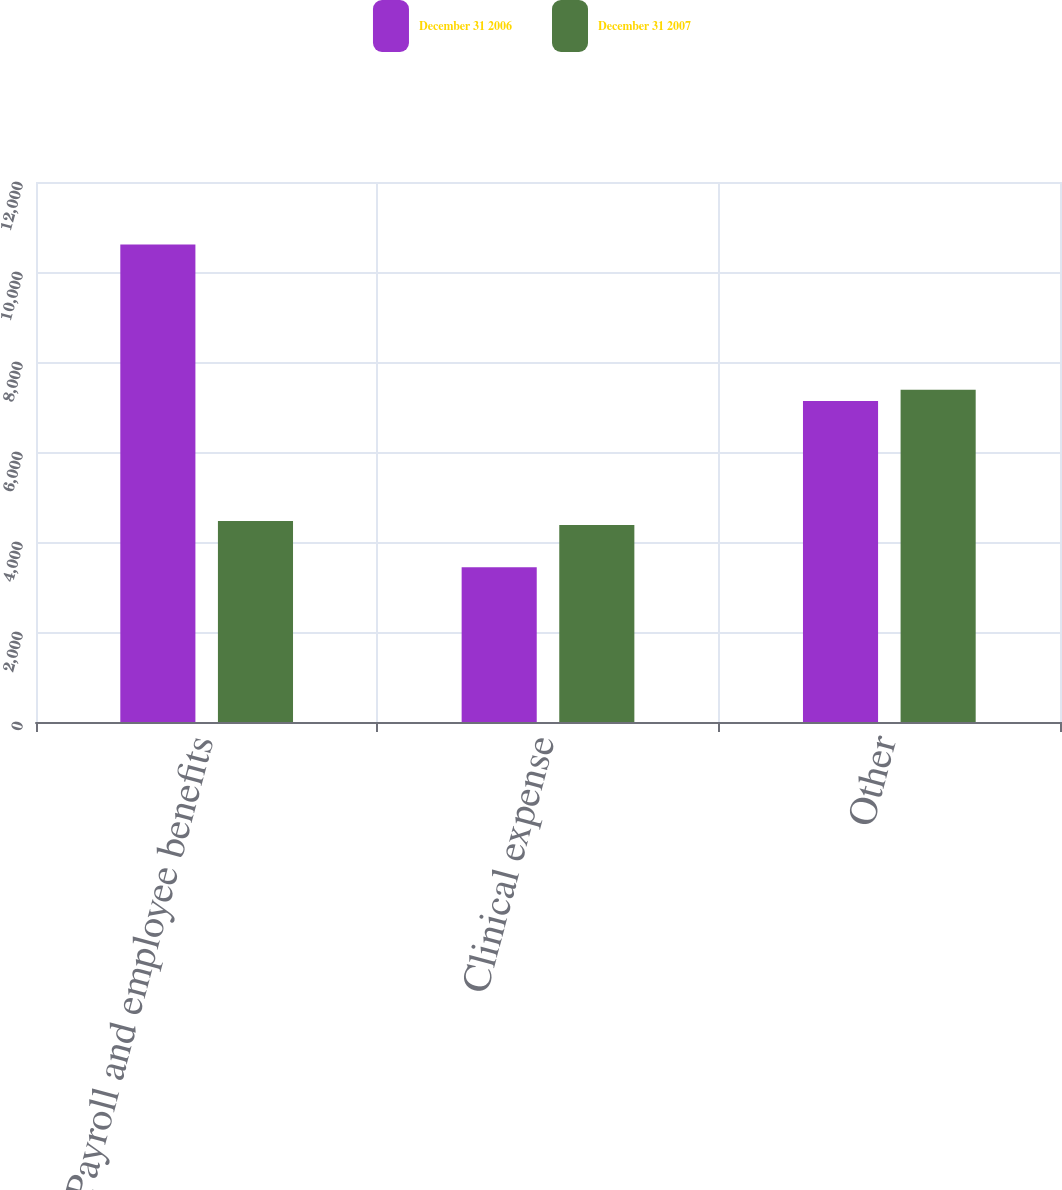Convert chart. <chart><loc_0><loc_0><loc_500><loc_500><stacked_bar_chart><ecel><fcel>Payroll and employee benefits<fcel>Clinical expense<fcel>Other<nl><fcel>December 31 2006<fcel>10610<fcel>3437<fcel>7132<nl><fcel>December 31 2007<fcel>4465<fcel>4379<fcel>7384<nl></chart> 